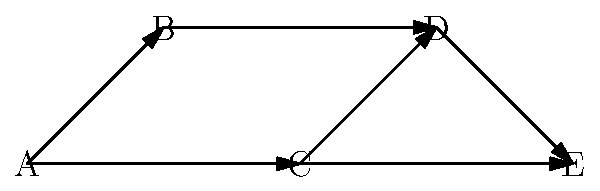Given the directed graph representing Python package dependencies, where each node represents a package and each edge represents a dependency, what is the maximum number of packages that need to be installed to use package E, assuming all other packages are already installed? To determine the maximum number of packages needed to install package E, we need to find the longest path from any starting node to E. Let's analyze the paths:

1. Start from A:
   A → B → D → E (4 packages)
   A → C → D → E (4 packages)
   A → C → E (3 packages)

2. Start from B:
   B → D → E (3 packages)

3. Start from C:
   C → D → E (3 packages)
   C → E (2 packages)

4. Start from D:
   D → E (2 packages)

5. Start from E:
   E (1 package)

The longest path is A → B → D → E or A → C → D → E, both requiring 4 packages.

This represents the worst-case scenario where none of the required packages are installed, and we need to install the maximum number of dependencies to use package E.
Answer: 4 